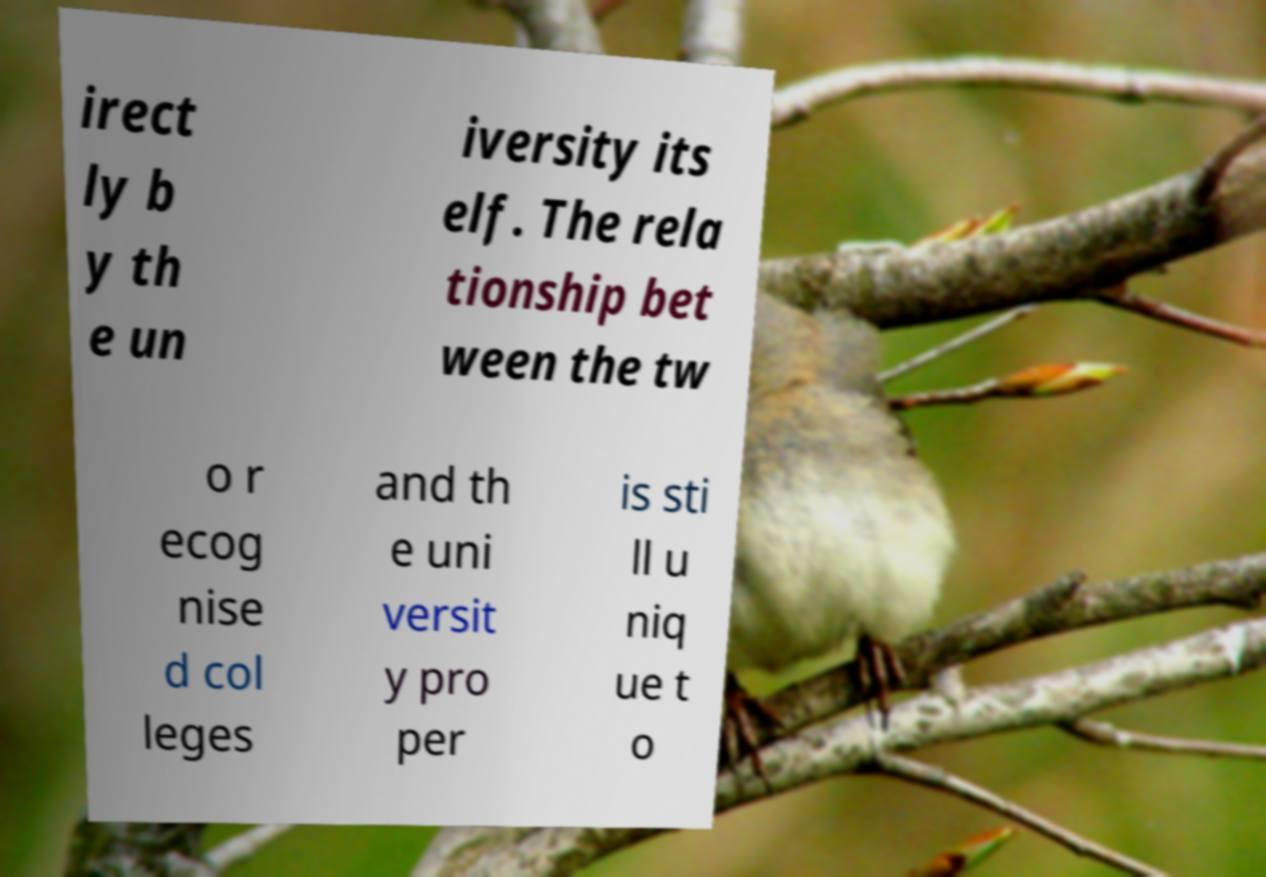What messages or text are displayed in this image? I need them in a readable, typed format. irect ly b y th e un iversity its elf. The rela tionship bet ween the tw o r ecog nise d col leges and th e uni versit y pro per is sti ll u niq ue t o 